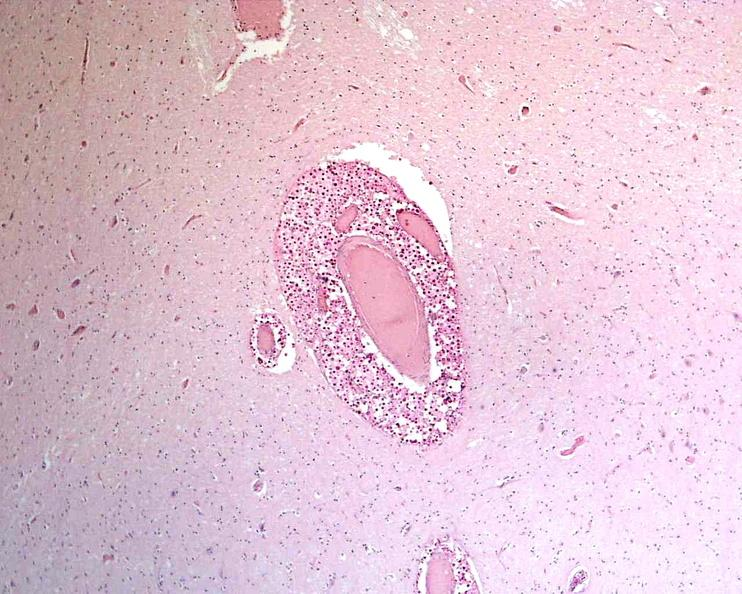where is this?
Answer the question using a single word or phrase. Nervous 